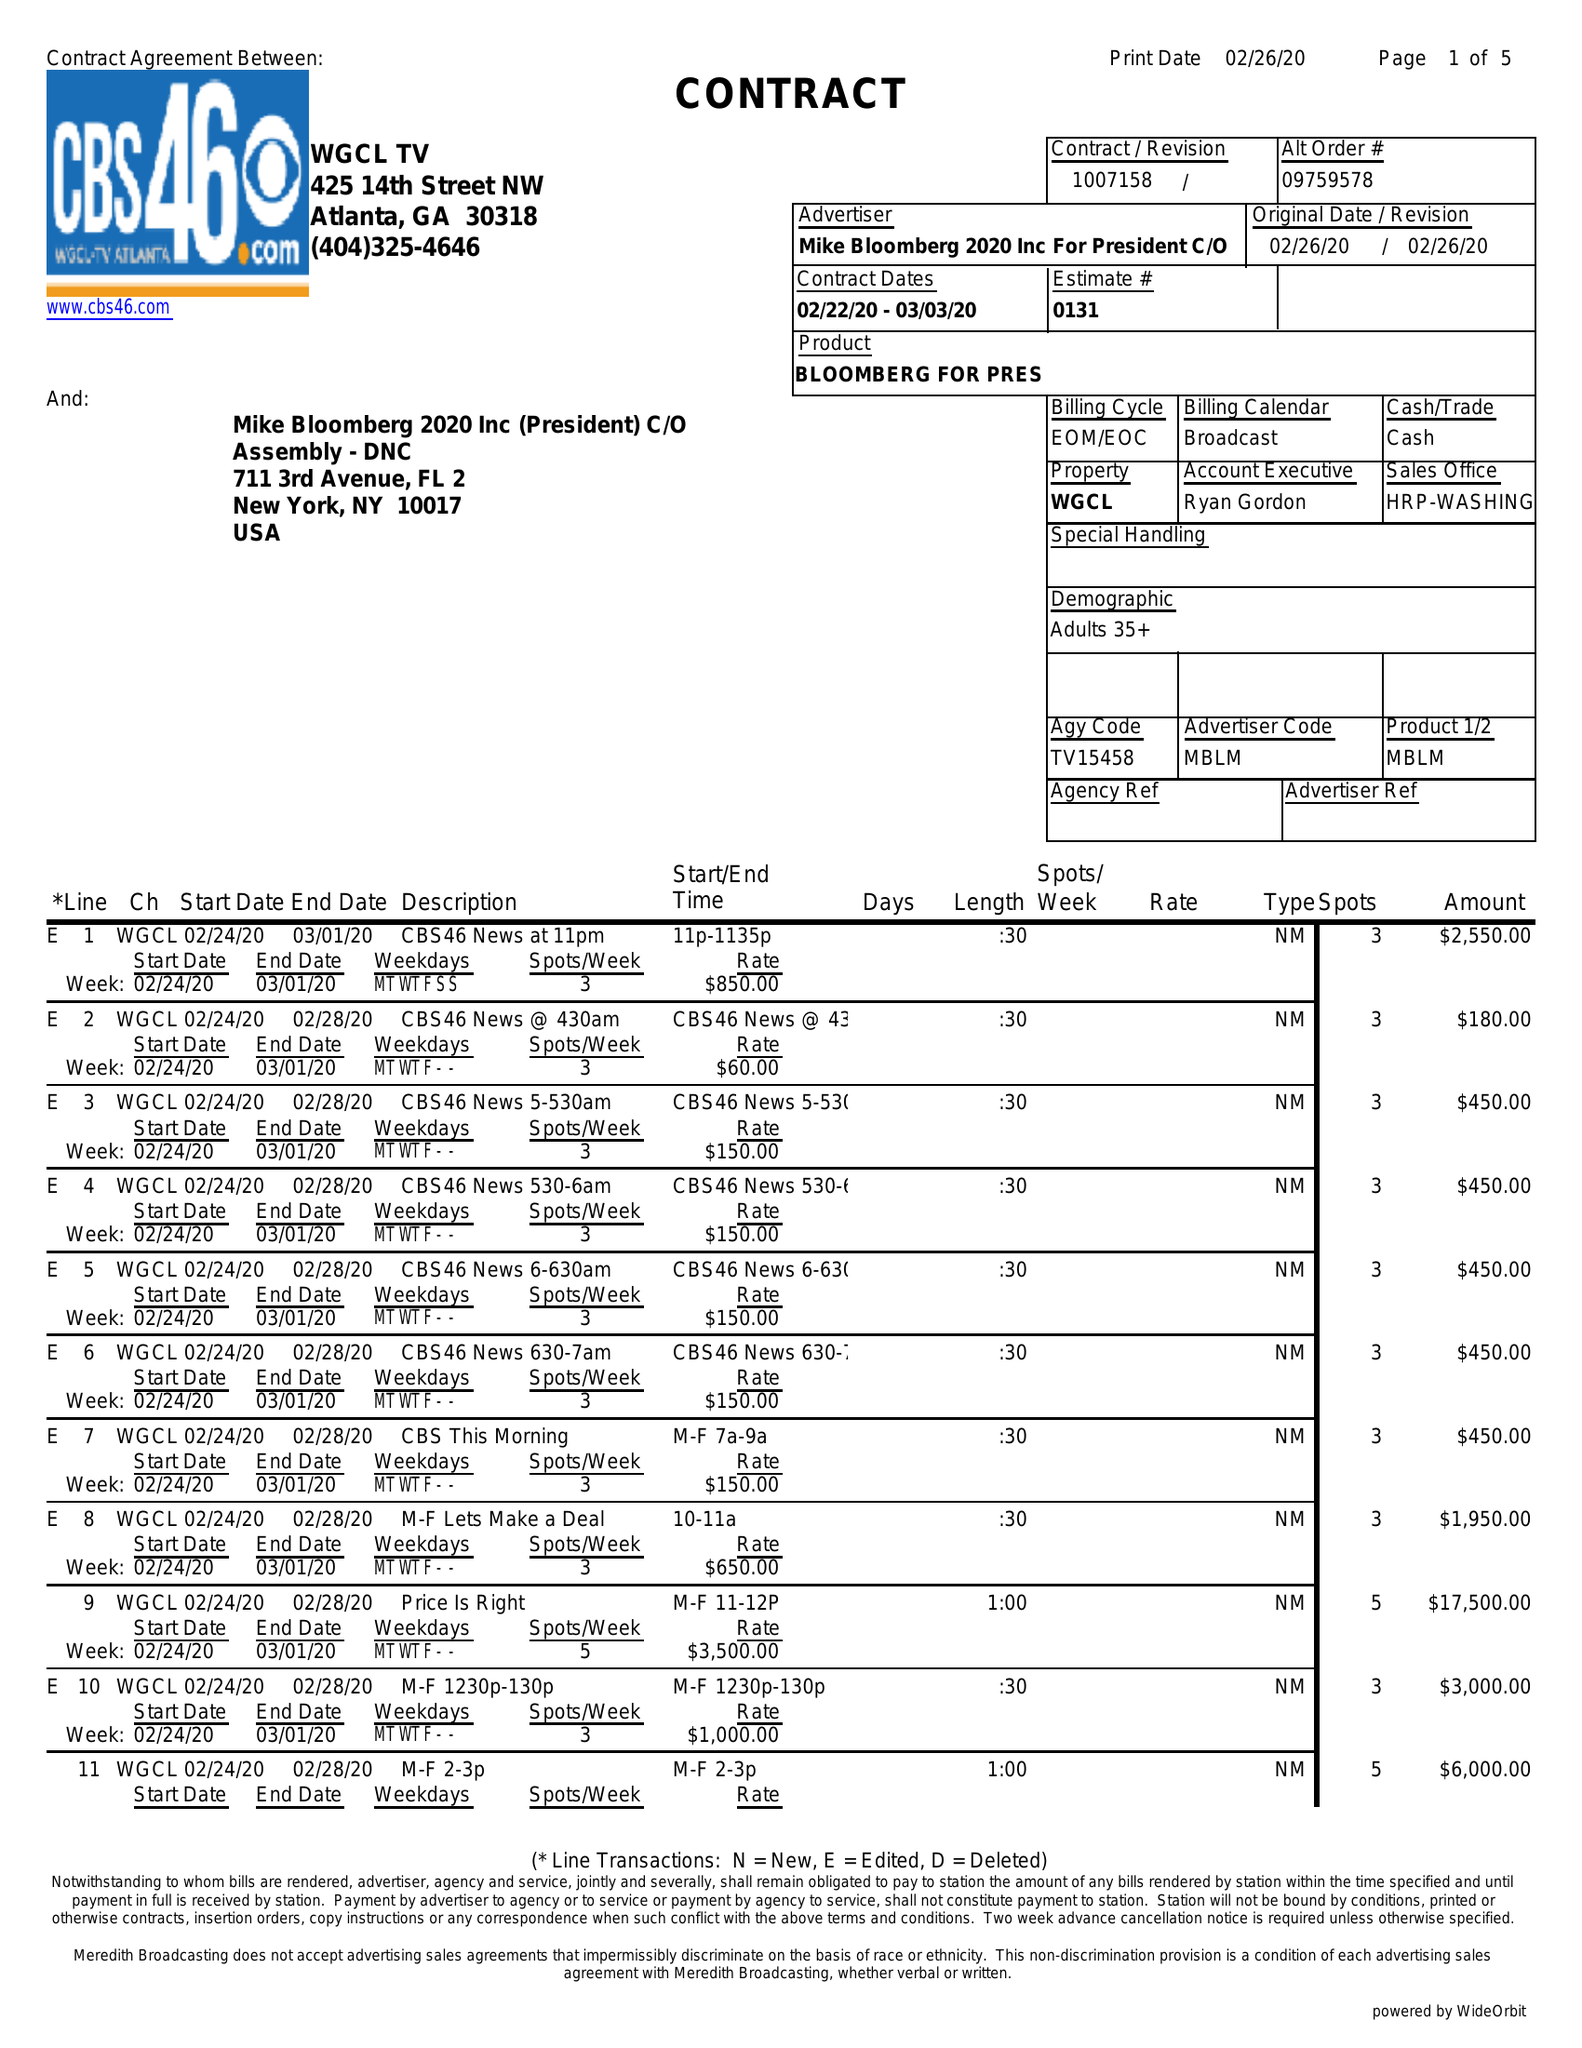What is the value for the advertiser?
Answer the question using a single word or phrase. MIKEBLOOMBERG2020INCFORPRESIDENTC/O 